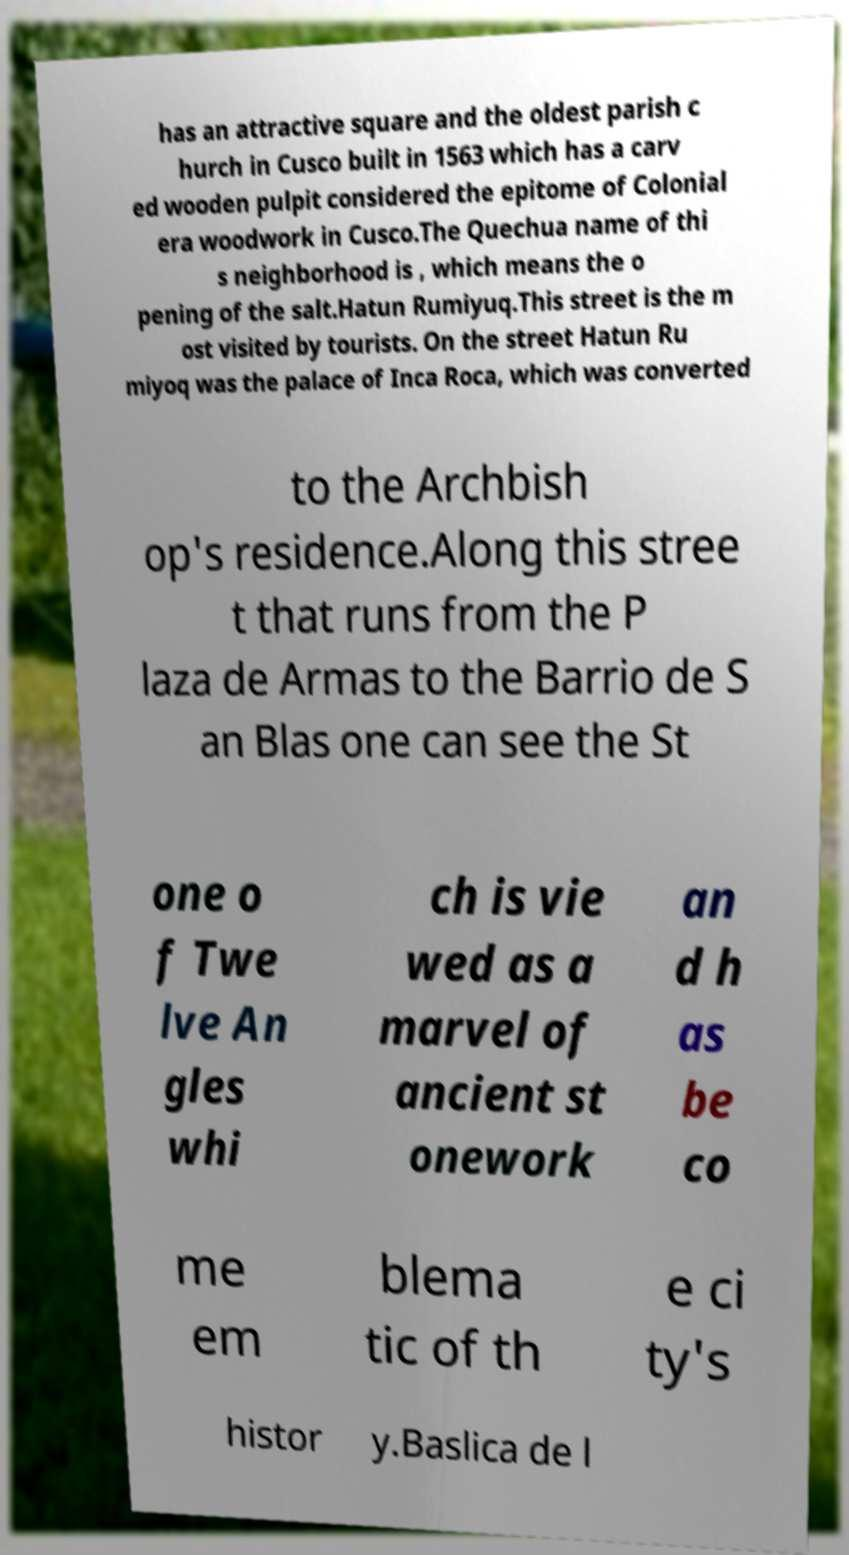Could you assist in decoding the text presented in this image and type it out clearly? has an attractive square and the oldest parish c hurch in Cusco built in 1563 which has a carv ed wooden pulpit considered the epitome of Colonial era woodwork in Cusco.The Quechua name of thi s neighborhood is , which means the o pening of the salt.Hatun Rumiyuq.This street is the m ost visited by tourists. On the street Hatun Ru miyoq was the palace of Inca Roca, which was converted to the Archbish op's residence.Along this stree t that runs from the P laza de Armas to the Barrio de S an Blas one can see the St one o f Twe lve An gles whi ch is vie wed as a marvel of ancient st onework an d h as be co me em blema tic of th e ci ty's histor y.Baslica de l 